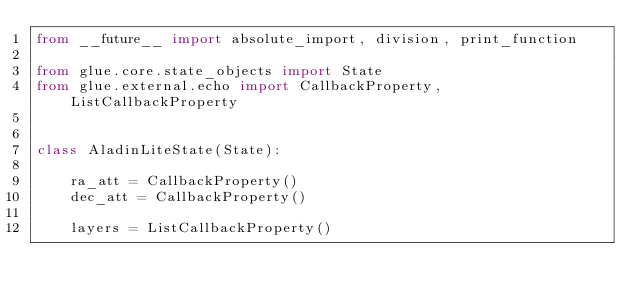<code> <loc_0><loc_0><loc_500><loc_500><_Python_>from __future__ import absolute_import, division, print_function

from glue.core.state_objects import State
from glue.external.echo import CallbackProperty, ListCallbackProperty


class AladinLiteState(State):

    ra_att = CallbackProperty()
    dec_att = CallbackProperty()

    layers = ListCallbackProperty()
</code> 